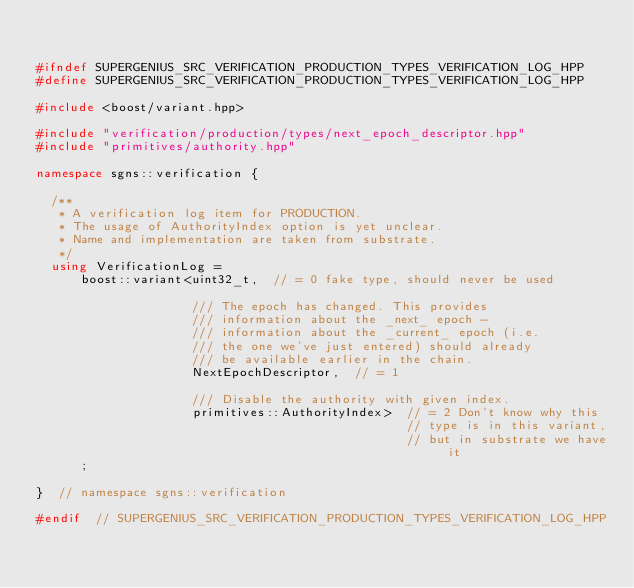<code> <loc_0><loc_0><loc_500><loc_500><_C++_>

#ifndef SUPERGENIUS_SRC_VERIFICATION_PRODUCTION_TYPES_VERIFICATION_LOG_HPP
#define SUPERGENIUS_SRC_VERIFICATION_PRODUCTION_TYPES_VERIFICATION_LOG_HPP

#include <boost/variant.hpp>

#include "verification/production/types/next_epoch_descriptor.hpp"
#include "primitives/authority.hpp"

namespace sgns::verification {

  /**
   * A verification log item for PRODUCTION.
   * The usage of AuthorityIndex option is yet unclear.
   * Name and implementation are taken from substrate.
   */
  using VerificationLog =
      boost::variant<uint32_t,  // = 0 fake type, should never be used

                     /// The epoch has changed. This provides
                     /// information about the _next_ epoch -
                     /// information about the _current_ epoch (i.e.
                     /// the one we've just entered) should already
                     /// be available earlier in the chain.
                     NextEpochDescriptor,  // = 1

                     /// Disable the authority with given index.
                     primitives::AuthorityIndex>  // = 2 Don't know why this
                                                  // type is in this variant,
                                                  // but in substrate we have it
      ;

}  // namespace sgns::verification

#endif  // SUPERGENIUS_SRC_VERIFICATION_PRODUCTION_TYPES_VERIFICATION_LOG_HPP
</code> 